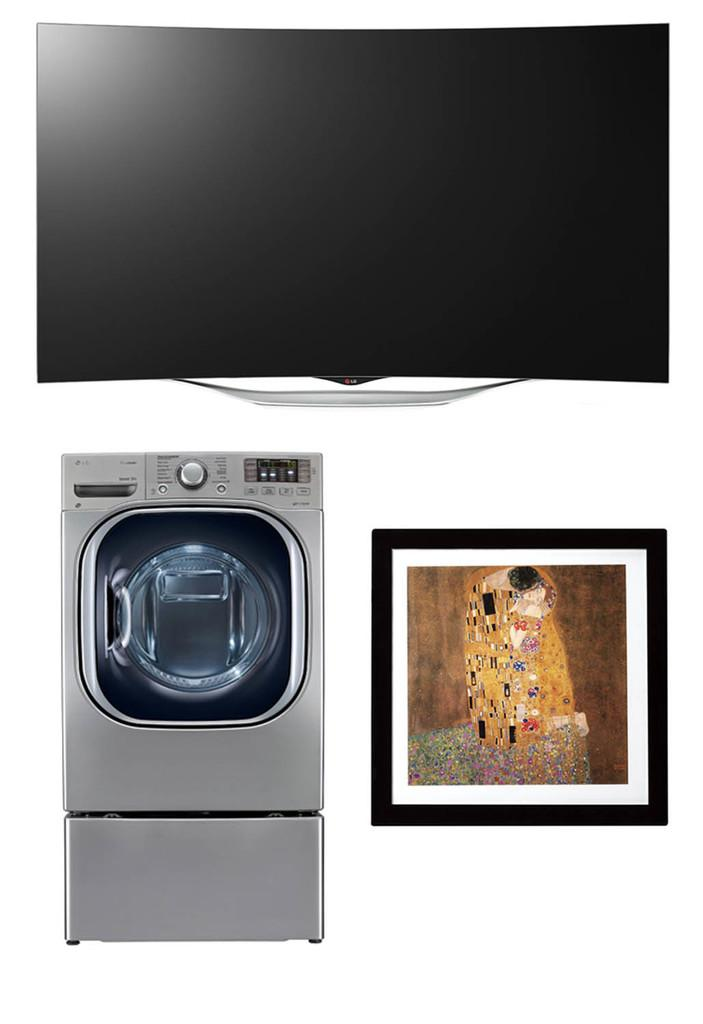What type of electronic device is visible in the image? There is an LED TV in the image. What appliance can be seen in the image for cleaning clothes? There is a washing machine in the image. What object is present in the image for displaying photos? There is a photo frame in the image. What type of crook is depicted in the photo frame in the image? There is no crook depicted in the image, as the photo frame is for displaying photos, not for showing images of crooks. 